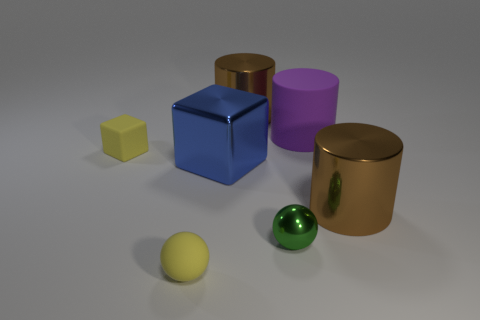Add 2 purple objects. How many objects exist? 9 Subtract all cylinders. How many objects are left? 4 Add 1 big objects. How many big objects are left? 5 Add 3 purple cylinders. How many purple cylinders exist? 4 Subtract 0 red blocks. How many objects are left? 7 Subtract all purple spheres. Subtract all tiny rubber blocks. How many objects are left? 6 